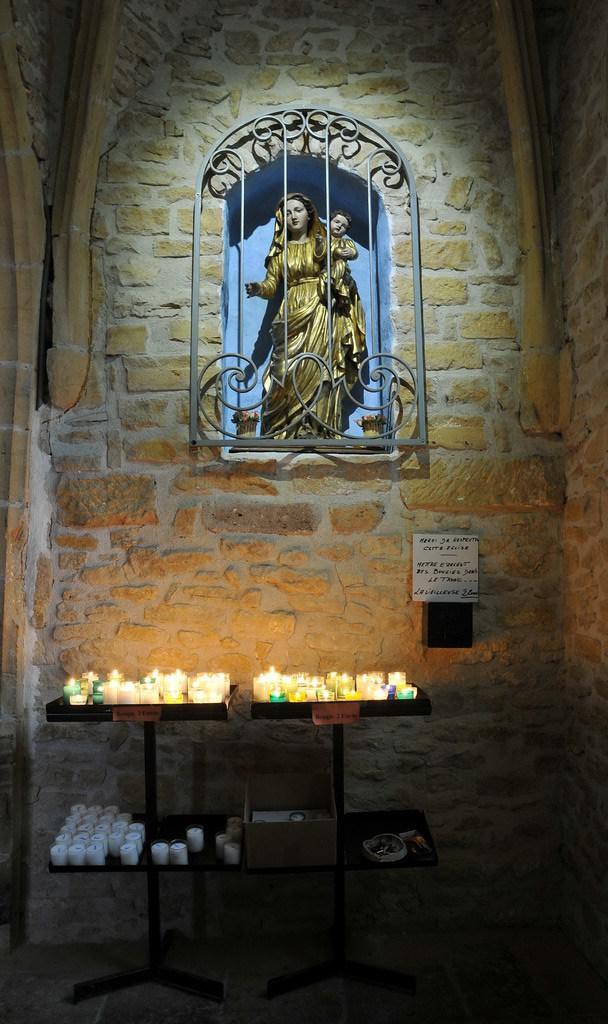Describe this image in one or two sentences. In the middle there are statues in this wall and these are the candles on this table. 